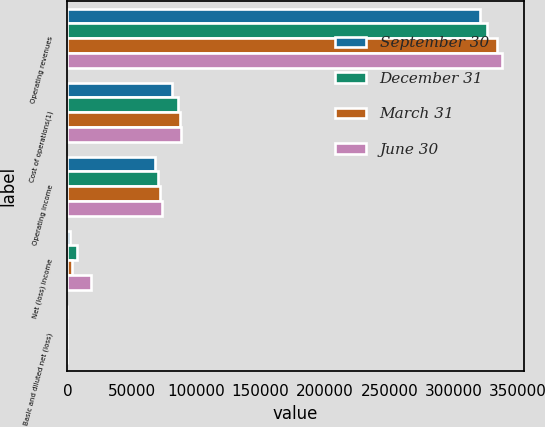Convert chart to OTSL. <chart><loc_0><loc_0><loc_500><loc_500><stacked_bar_chart><ecel><fcel>Operating revenues<fcel>Cost of operations(1)<fcel>Operating income<fcel>Net (loss) income<fcel>Basic and diluted net (loss)<nl><fcel>September 30<fcel>320409<fcel>81612<fcel>67709<fcel>1937<fcel>0.01<nl><fcel>December 31<fcel>325863<fcel>85737<fcel>70772<fcel>7664<fcel>0.02<nl><fcel>March 31<fcel>333467<fcel>87562<fcel>72007<fcel>3472<fcel>0.01<nl><fcel>June 30<fcel>337646<fcel>88626<fcel>73413<fcel>18285<fcel>0.04<nl></chart> 